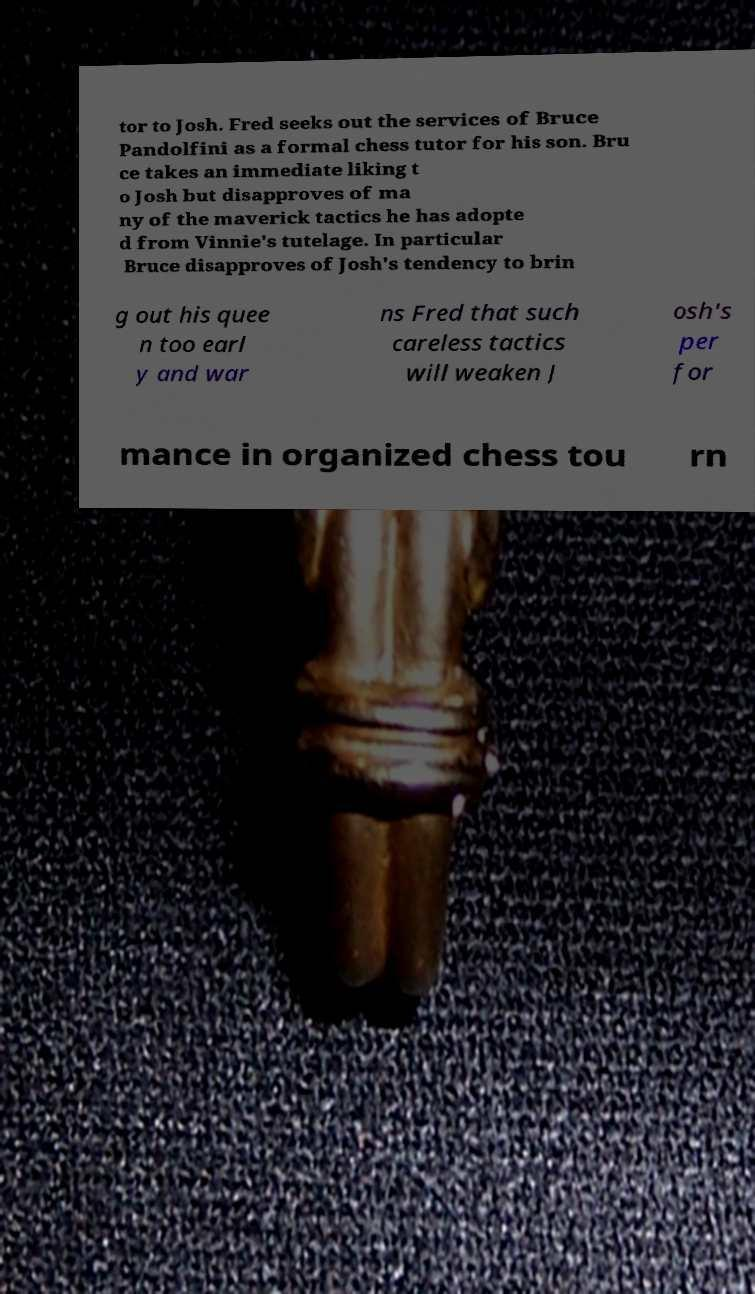Could you assist in decoding the text presented in this image and type it out clearly? tor to Josh. Fred seeks out the services of Bruce Pandolfini as a formal chess tutor for his son. Bru ce takes an immediate liking t o Josh but disapproves of ma ny of the maverick tactics he has adopte d from Vinnie's tutelage. In particular Bruce disapproves of Josh's tendency to brin g out his quee n too earl y and war ns Fred that such careless tactics will weaken J osh's per for mance in organized chess tou rn 